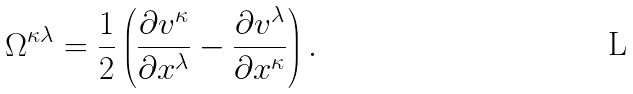<formula> <loc_0><loc_0><loc_500><loc_500>\Omega ^ { \kappa \lambda } = \frac { 1 } { 2 } \left ( \frac { \partial v ^ { \kappa } } { \partial x ^ { \lambda } } - \frac { \partial v ^ { \lambda } } { \partial x ^ { \kappa } } \right ) .</formula> 